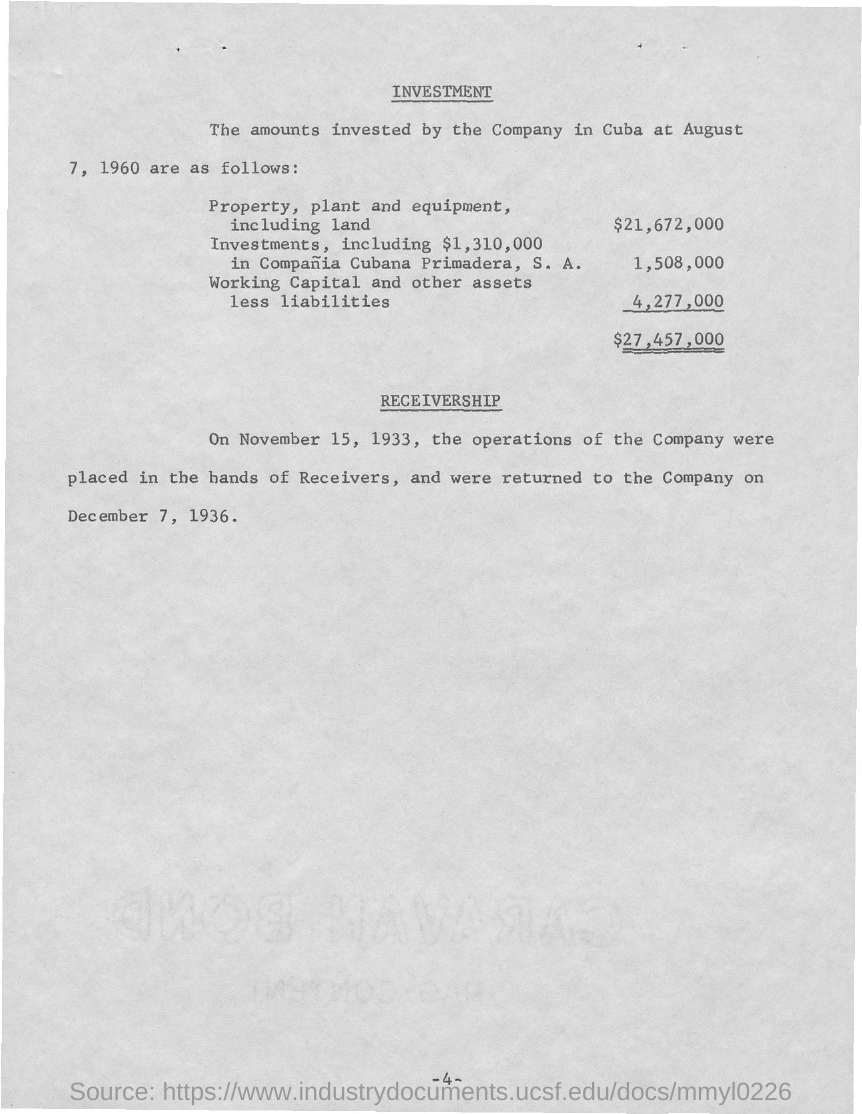What is the first title in the document?
Keep it short and to the point. INVESTMENT. What is the second title in this document?
Offer a terse response. Receivership. 